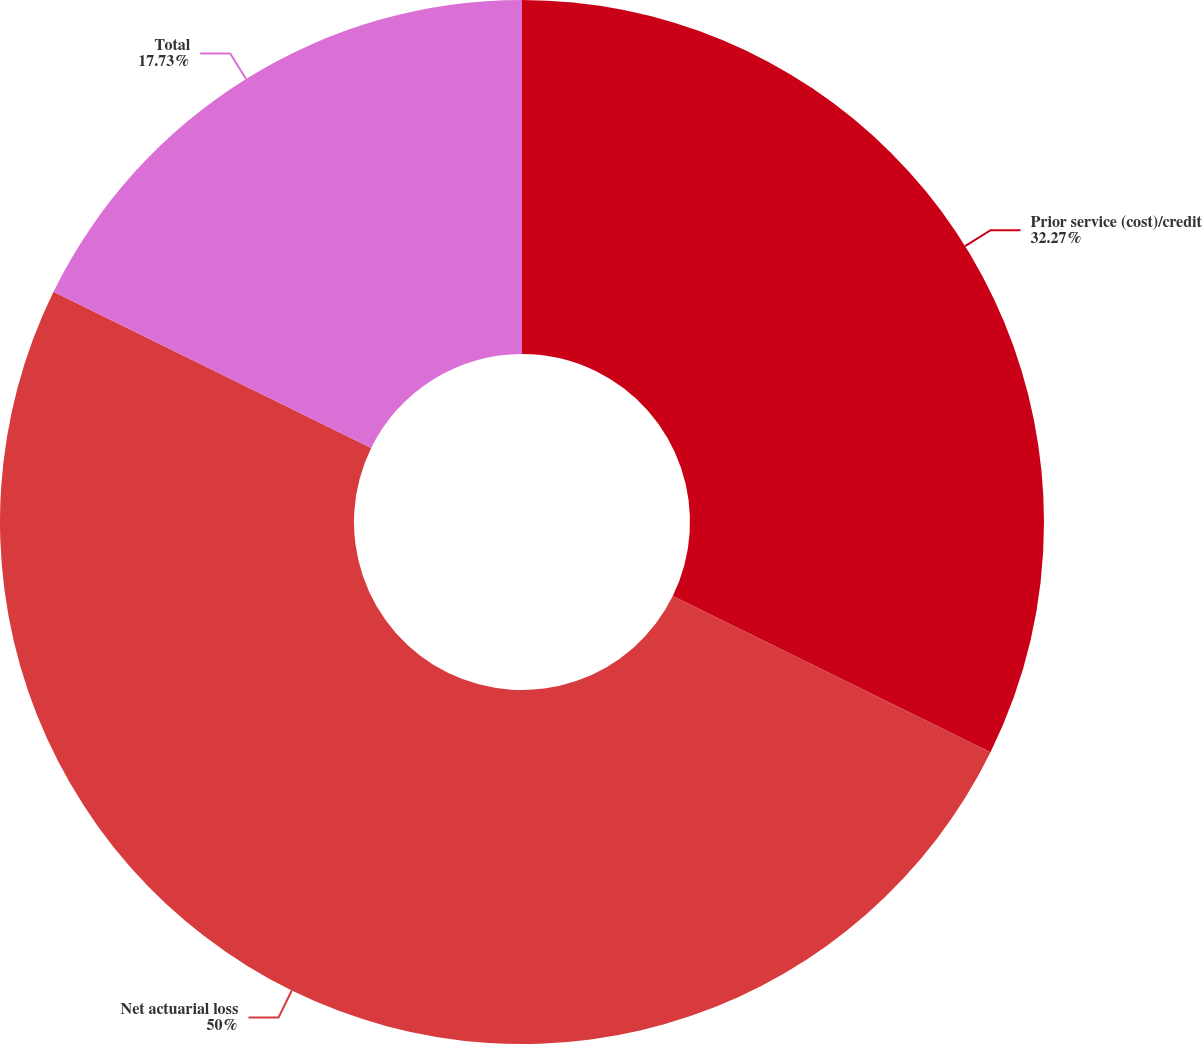<chart> <loc_0><loc_0><loc_500><loc_500><pie_chart><fcel>Prior service (cost)/credit<fcel>Net actuarial loss<fcel>Total<nl><fcel>32.27%<fcel>50.0%<fcel>17.73%<nl></chart> 